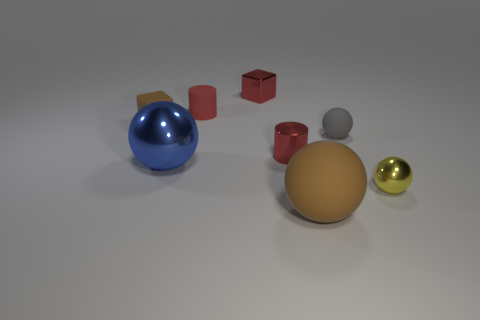Subtract 1 spheres. How many spheres are left? 3 Add 2 big brown things. How many objects exist? 10 Subtract all cylinders. How many objects are left? 6 Subtract 1 gray balls. How many objects are left? 7 Subtract all big blue metallic spheres. Subtract all yellow metallic balls. How many objects are left? 6 Add 8 big blue metallic spheres. How many big blue metallic spheres are left? 9 Add 4 brown shiny blocks. How many brown shiny blocks exist? 4 